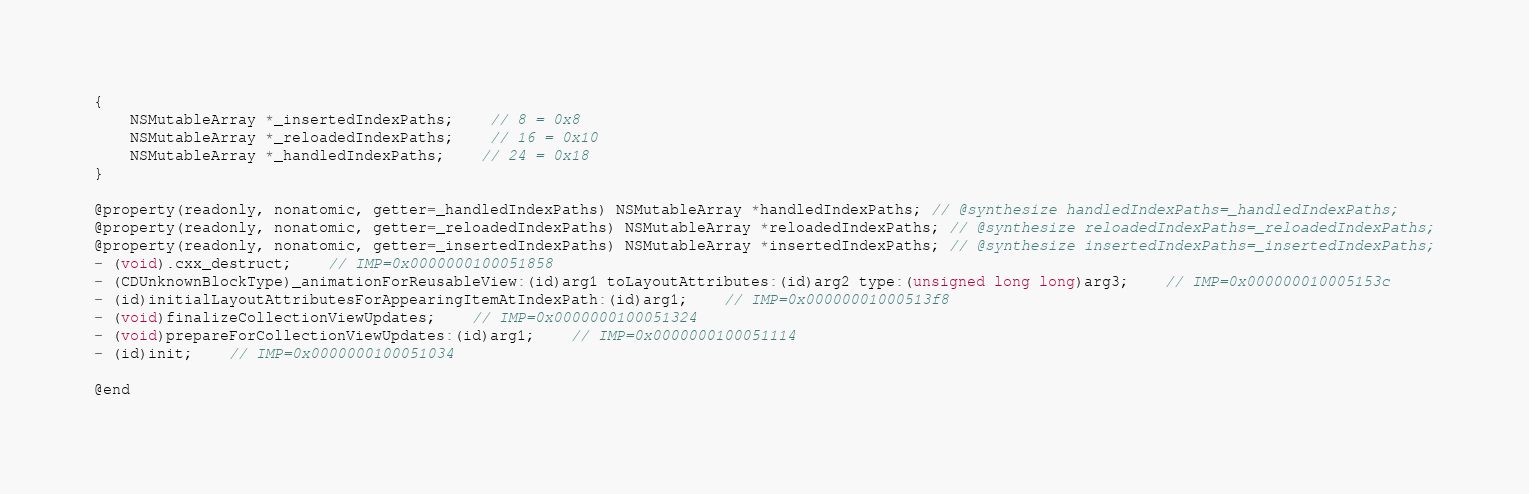<code> <loc_0><loc_0><loc_500><loc_500><_C_>{
    NSMutableArray *_insertedIndexPaths;	// 8 = 0x8
    NSMutableArray *_reloadedIndexPaths;	// 16 = 0x10
    NSMutableArray *_handledIndexPaths;	// 24 = 0x18
}

@property(readonly, nonatomic, getter=_handledIndexPaths) NSMutableArray *handledIndexPaths; // @synthesize handledIndexPaths=_handledIndexPaths;
@property(readonly, nonatomic, getter=_reloadedIndexPaths) NSMutableArray *reloadedIndexPaths; // @synthesize reloadedIndexPaths=_reloadedIndexPaths;
@property(readonly, nonatomic, getter=_insertedIndexPaths) NSMutableArray *insertedIndexPaths; // @synthesize insertedIndexPaths=_insertedIndexPaths;
- (void).cxx_destruct;	// IMP=0x0000000100051858
- (CDUnknownBlockType)_animationForReusableView:(id)arg1 toLayoutAttributes:(id)arg2 type:(unsigned long long)arg3;	// IMP=0x000000010005153c
- (id)initialLayoutAttributesForAppearingItemAtIndexPath:(id)arg1;	// IMP=0x00000001000513f8
- (void)finalizeCollectionViewUpdates;	// IMP=0x0000000100051324
- (void)prepareForCollectionViewUpdates:(id)arg1;	// IMP=0x0000000100051114
- (id)init;	// IMP=0x0000000100051034

@end

</code> 